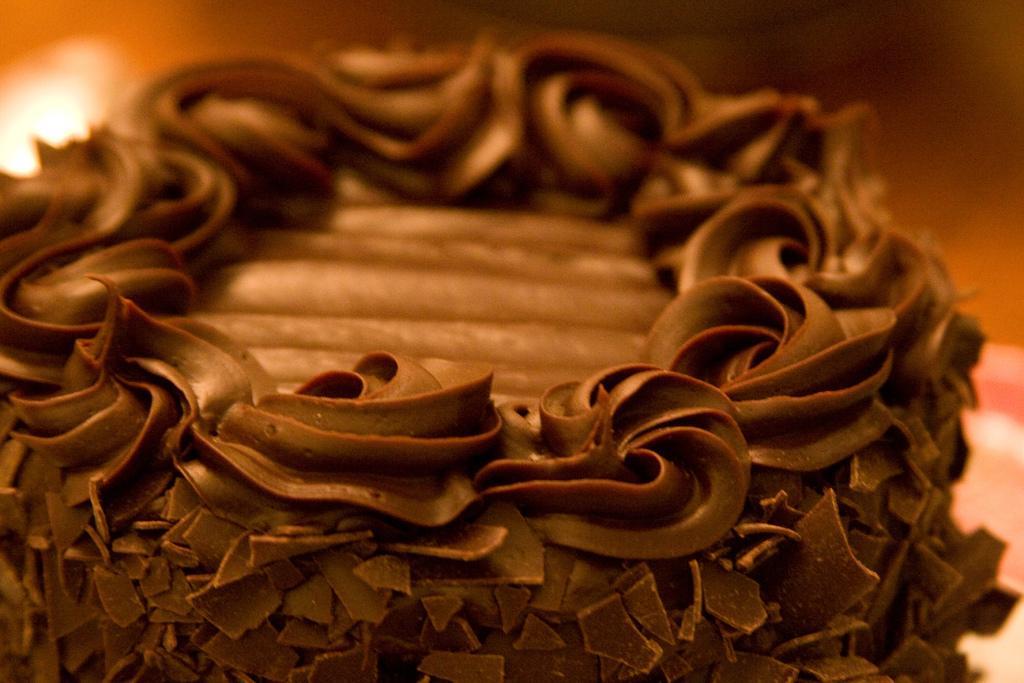Can you describe this image briefly? In the image we can see some food. Background of the image is blur. 